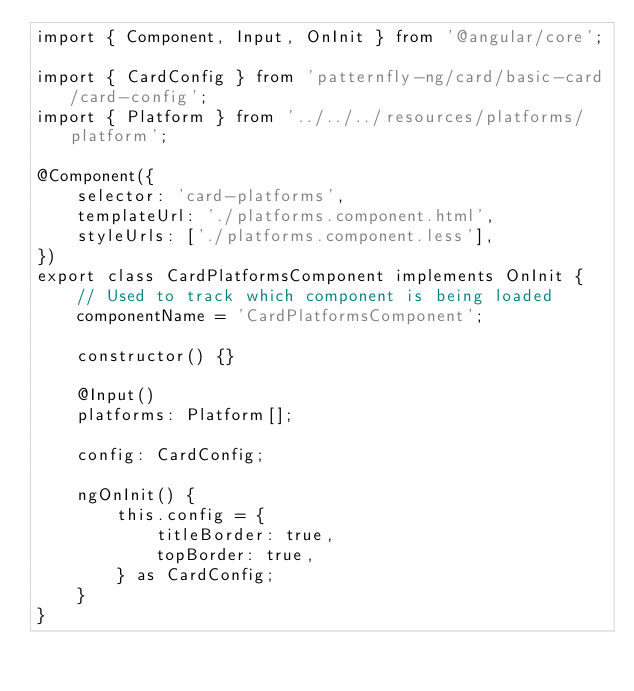Convert code to text. <code><loc_0><loc_0><loc_500><loc_500><_TypeScript_>import { Component, Input, OnInit } from '@angular/core';

import { CardConfig } from 'patternfly-ng/card/basic-card/card-config';
import { Platform } from '../../../resources/platforms/platform';

@Component({
    selector: 'card-platforms',
    templateUrl: './platforms.component.html',
    styleUrls: ['./platforms.component.less'],
})
export class CardPlatformsComponent implements OnInit {
    // Used to track which component is being loaded
    componentName = 'CardPlatformsComponent';

    constructor() {}

    @Input()
    platforms: Platform[];

    config: CardConfig;

    ngOnInit() {
        this.config = {
            titleBorder: true,
            topBorder: true,
        } as CardConfig;
    }
}
</code> 